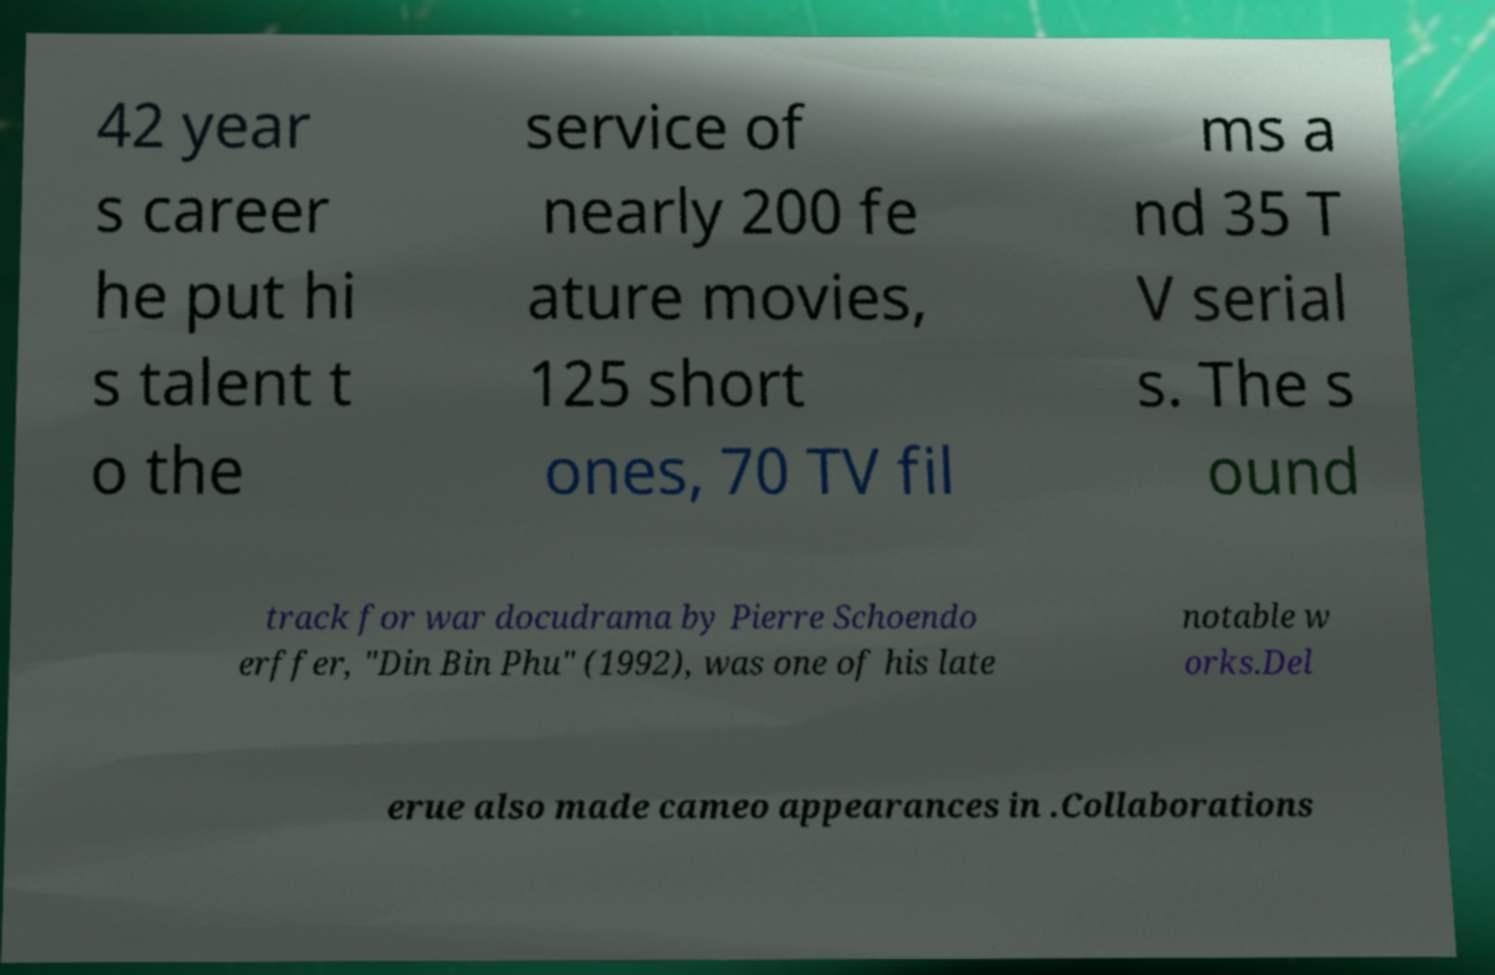For documentation purposes, I need the text within this image transcribed. Could you provide that? 42 year s career he put hi s talent t o the service of nearly 200 fe ature movies, 125 short ones, 70 TV fil ms a nd 35 T V serial s. The s ound track for war docudrama by Pierre Schoendo erffer, "Din Bin Phu" (1992), was one of his late notable w orks.Del erue also made cameo appearances in .Collaborations 